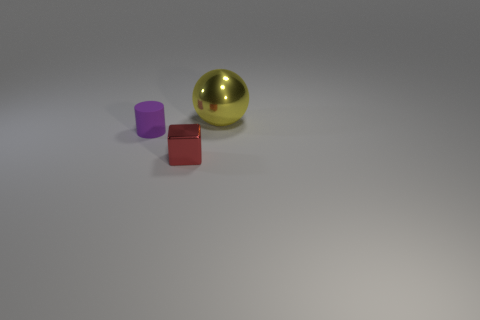Add 1 large yellow balls. How many objects exist? 4 Subtract all cylinders. How many objects are left? 2 Add 3 purple metallic spheres. How many purple metallic spheres exist? 3 Subtract 0 red cylinders. How many objects are left? 3 Subtract all small purple cylinders. Subtract all red cubes. How many objects are left? 1 Add 3 yellow balls. How many yellow balls are left? 4 